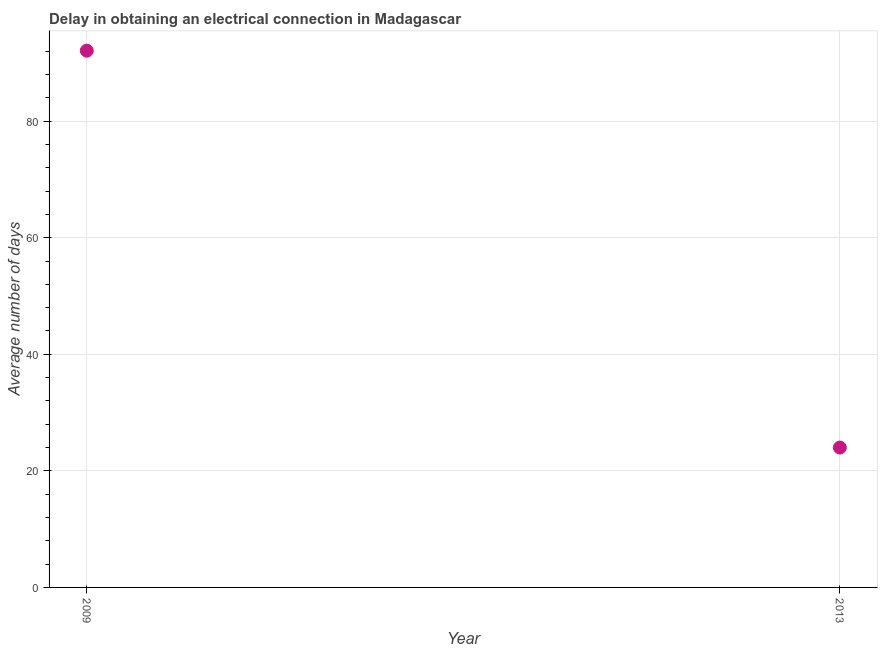What is the dalay in electrical connection in 2013?
Provide a succinct answer. 24. Across all years, what is the maximum dalay in electrical connection?
Ensure brevity in your answer.  92.1. What is the sum of the dalay in electrical connection?
Your answer should be very brief. 116.1. What is the difference between the dalay in electrical connection in 2009 and 2013?
Your answer should be very brief. 68.1. What is the average dalay in electrical connection per year?
Offer a terse response. 58.05. What is the median dalay in electrical connection?
Keep it short and to the point. 58.05. In how many years, is the dalay in electrical connection greater than 60 days?
Offer a terse response. 1. Do a majority of the years between 2009 and 2013 (inclusive) have dalay in electrical connection greater than 12 days?
Offer a very short reply. Yes. What is the ratio of the dalay in electrical connection in 2009 to that in 2013?
Keep it short and to the point. 3.84. Is the dalay in electrical connection in 2009 less than that in 2013?
Your answer should be very brief. No. How many dotlines are there?
Your answer should be compact. 1. How many years are there in the graph?
Your answer should be compact. 2. What is the difference between two consecutive major ticks on the Y-axis?
Provide a short and direct response. 20. Does the graph contain any zero values?
Provide a succinct answer. No. What is the title of the graph?
Offer a very short reply. Delay in obtaining an electrical connection in Madagascar. What is the label or title of the X-axis?
Give a very brief answer. Year. What is the label or title of the Y-axis?
Your response must be concise. Average number of days. What is the Average number of days in 2009?
Ensure brevity in your answer.  92.1. What is the difference between the Average number of days in 2009 and 2013?
Ensure brevity in your answer.  68.1. What is the ratio of the Average number of days in 2009 to that in 2013?
Your answer should be compact. 3.84. 